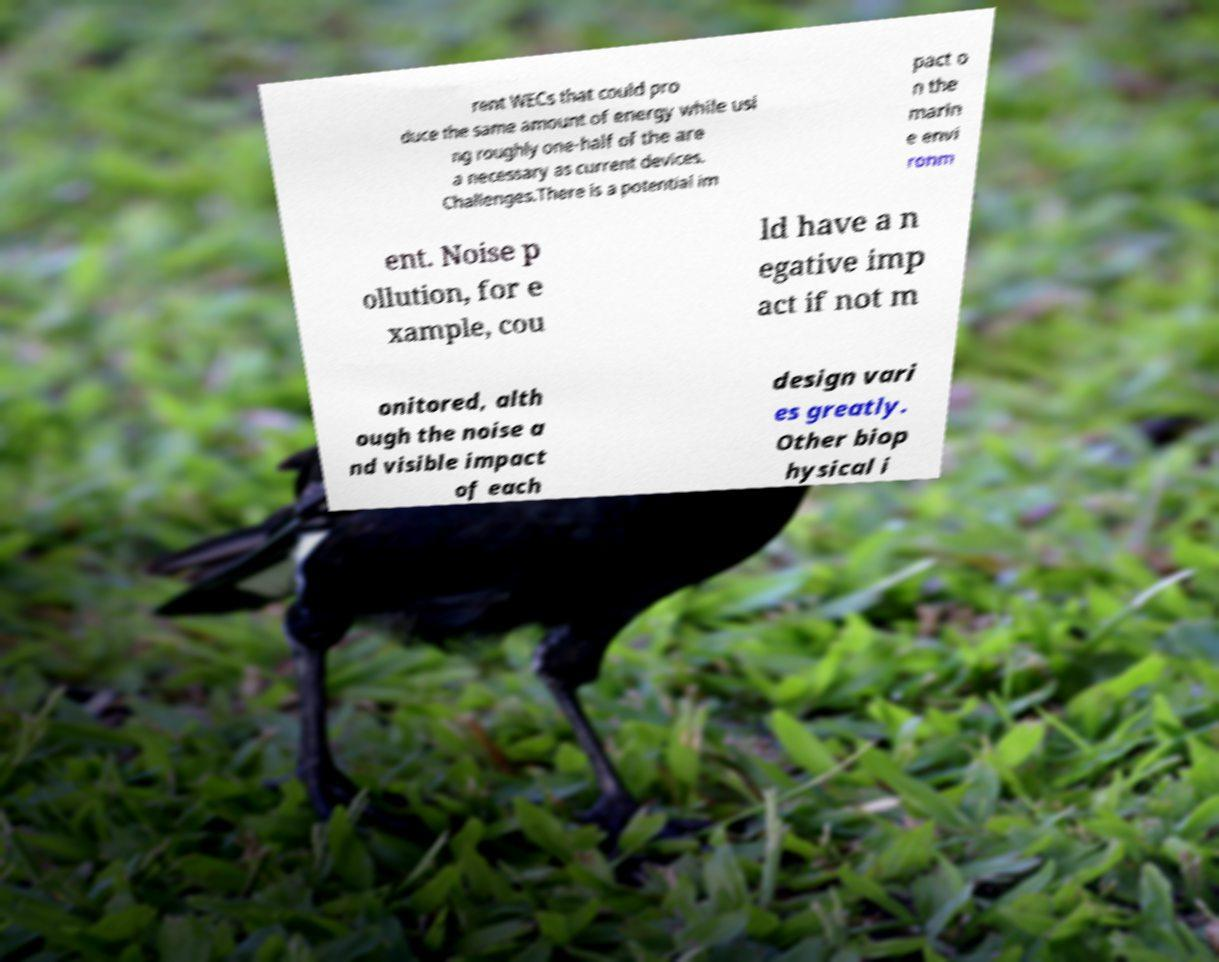Can you accurately transcribe the text from the provided image for me? rent WECs that could pro duce the same amount of energy while usi ng roughly one-half of the are a necessary as current devices. Challenges.There is a potential im pact o n the marin e envi ronm ent. Noise p ollution, for e xample, cou ld have a n egative imp act if not m onitored, alth ough the noise a nd visible impact of each design vari es greatly. Other biop hysical i 